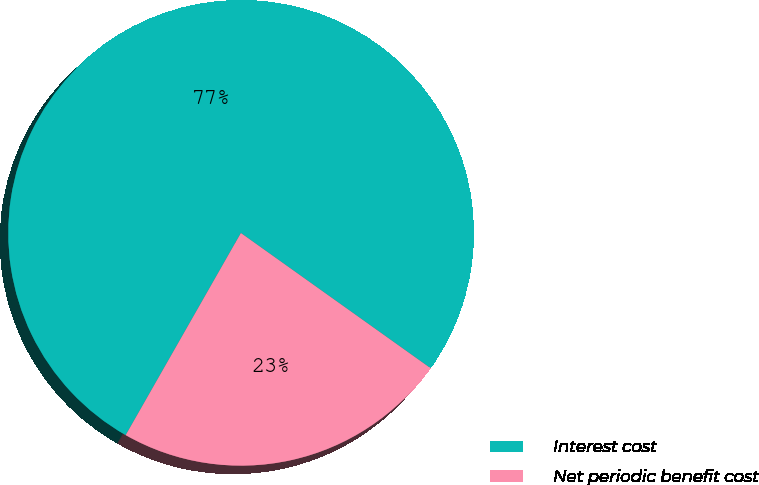Convert chart to OTSL. <chart><loc_0><loc_0><loc_500><loc_500><pie_chart><fcel>Interest cost<fcel>Net periodic benefit cost<nl><fcel>76.61%<fcel>23.39%<nl></chart> 